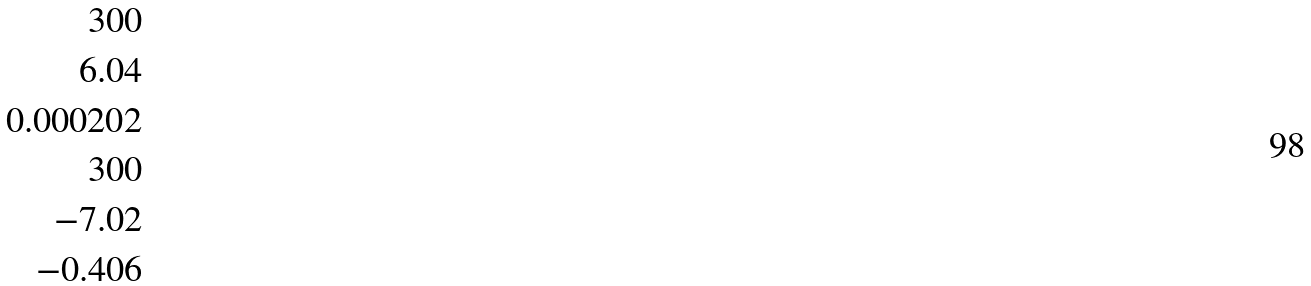<formula> <loc_0><loc_0><loc_500><loc_500>3 0 0 \\ 6 . 0 4 \\ 0 . 0 0 0 2 0 2 \\ 3 0 0 \\ - 7 . 0 2 \\ - 0 . 4 0 6</formula> 